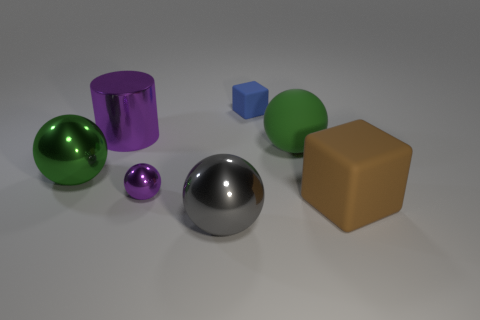Subtract all purple cubes. Subtract all brown cylinders. How many cubes are left? 2 Add 2 big gray objects. How many objects exist? 9 Subtract all spheres. How many objects are left? 3 Subtract 0 brown cylinders. How many objects are left? 7 Subtract all gray balls. Subtract all small purple metal objects. How many objects are left? 5 Add 5 big brown rubber blocks. How many big brown rubber blocks are left? 6 Add 1 small rubber things. How many small rubber things exist? 2 